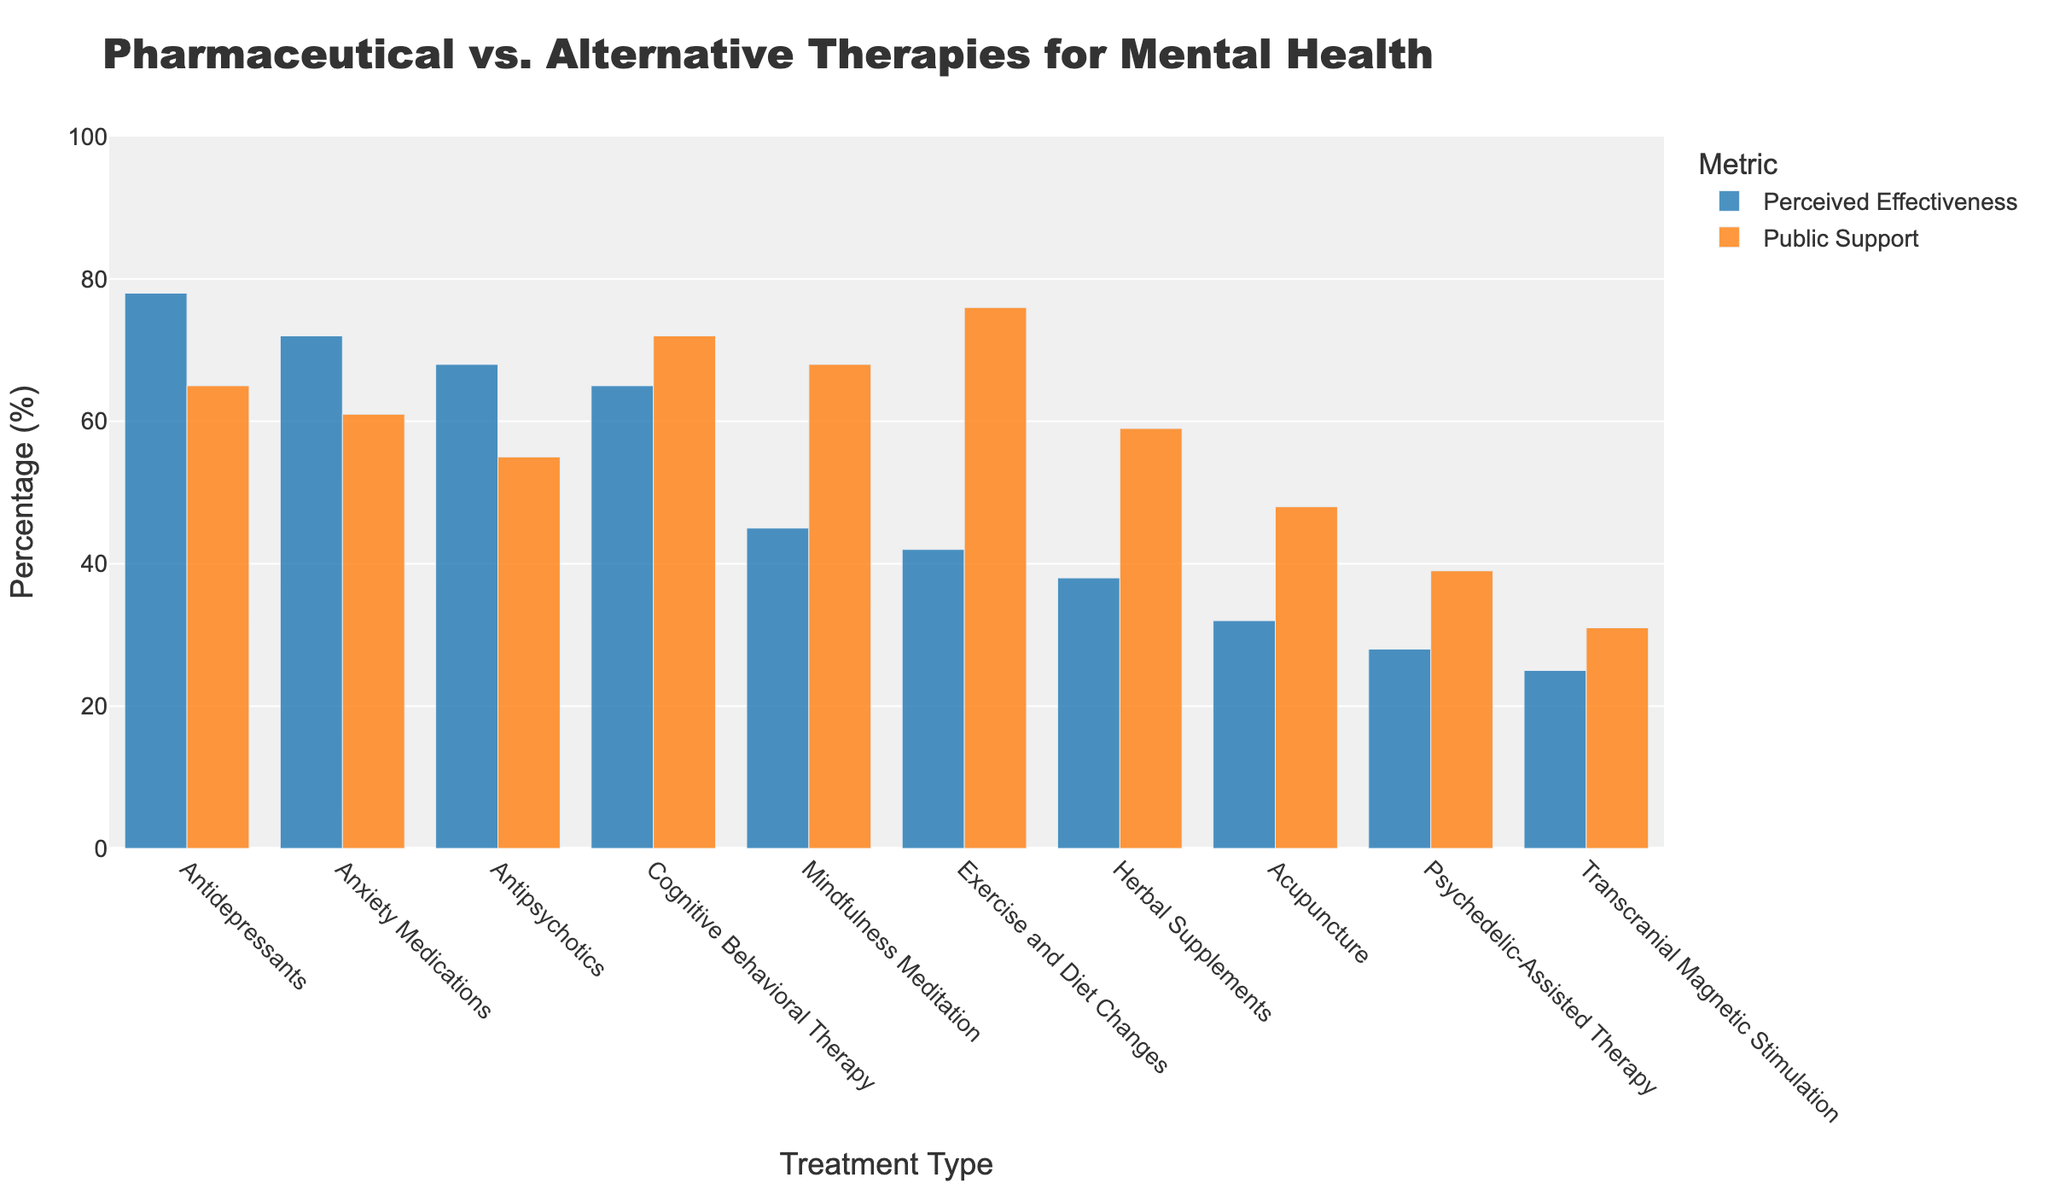Which treatment type has the highest perceived effectiveness? To determine this, look for the bar with the highest height in the "Perceived Effectiveness" category. The tallest bar represents Antidepressants at 78%.
Answer: Antidepressants What is the difference in public support between Cognitive Behavioral Therapy and Antipsychotics? First, identify the public support percentages for both treatments: Cognitive Behavioral Therapy is 72% and Antipsychotics is 55%. Subtract the lower value from the higher one: 72 - 55.
Answer: 17% Compare the perceived effectiveness of Herbal Supplements and Antipsychotics. Which one is perceived as more effective? Visual comparison shows that the bar for Antipsychotics is higher than that for Herbal Supplements. Antipsychotics has 68% perceived effectiveness while Herbal Supplements has 38%.
Answer: Antipsychotics Which treatment has a higher perceived effectiveness: Exercise and Diet Changes or Mindfulness Meditation? Compare the heights of the bars representing these treatments in the "Perceived Effectiveness" category. Mindfulness Meditation has 45%, and Exercise and Diet Changes have 42%.
Answer: Mindfulness Meditation Rank the following treatments from highest to lowest in public support: Exercise and Diet Changes, Antidepressants, and Mindfulness Meditation. Check each treatment's public support percentage and arrange them. Exercise and Diet Changes: 76%, Mindfulness Meditation: 68%, Antidepressants: 65%.
Answer: Exercise and Diet Changes > Mindfulness Meditation > Antidepressants How do the perceived effectiveness and public support of Acupuncture compare visually? Visually, the bar for perceived effectiveness of Acupuncture at 32% is notably shorter than the bar for its public support at 48%.
Answer: The public support bar is higher If we average the perceived effectiveness of Anxiety Medications, Antipsychotics, and Antidepressants, what would it be? First, add their values: 72% (Anxiety Medications) + 68% (Antipsychotics) + 78% (Antidepressants) = 218%. Then divide by the number of treatments: 218 / 3.
Answer: 72.67% Is there a treatment that has higher public support compared to its perceived effectiveness? Compare each treatment's perceived effectiveness and public support bars. Cognitive Behavioral Therapy (72% support, 65% effective), Mindfulness Meditation (68% support, 45% effective), and Exercise and Diet Changes (76% support, 42% effective) meet this criterion.
Answer: Yes, Cognitive Behavioral Therapy, Mindfulness Meditation, Exercise and Diet Changes What is the public support difference between Psychedelic-Assisted Therapy and Transcranial Magnetic Stimulation? Identify the public support percentages: Psychedelic-Assisted Therapy is 39% and Transcranial Magnetic Stimulation is 31%. Subtract the lower value from the higher one: 39 - 31.
Answer: 8% Which treatment type has the lowest perceived effectiveness, and what is its percentage? Look for the shortest bar in the "Perceived Effectiveness" category. Transcranial Magnetic Stimulation is the lowest with 25%.
Answer: Transcranial Magnetic Stimulation, 25% 